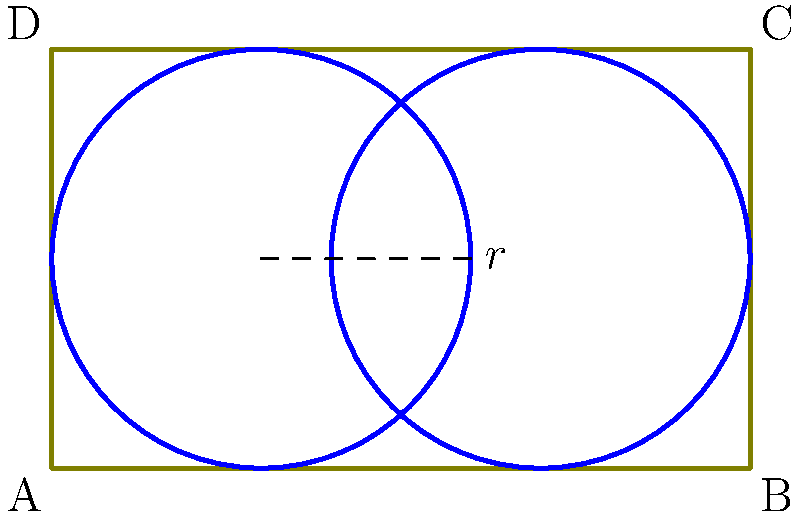As an agroecologist, you're designing an irrigation system for a rectangular field measuring 100 m by 60 m. You plan to use two circular pivot irrigation systems, each with a radius of 30 m. If the centers of the circles are placed on the long axis of the rectangle, what is the maximum percentage of the field that can be irrigated? Let's approach this step-by-step:

1) First, we need to calculate the total area of the field:
   Area of field = $100 \text{ m} \times 60 \text{ m} = 6000 \text{ m}^2$

2) The area of each circular irrigation system is:
   Area of circle = $\pi r^2 = \pi (30 \text{ m})^2 = 900\pi \text{ m}^2$

3) There are two circles, so the total irrigated area is:
   Total irrigated area = $2 \times 900\pi \text{ m}^2 = 1800\pi \text{ m}^2$

4) However, we need to check if the circles overlap or extend beyond the field:
   - The field is 100 m long, and each circle has a diameter of 60 m
   - If we place the centers of the circles 40 m apart (20 m from each end), they will just touch
   - This arrangement fits within the field and maximizes the irrigated area

5) Therefore, the maximum irrigated area is indeed $1800\pi \text{ m}^2$

6) To calculate the percentage, we divide the irrigated area by the total area and multiply by 100:
   Percentage irrigated = $\frac{1800\pi \text{ m}^2}{6000 \text{ m}^2} \times 100\% = 94.25\%$
Answer: 94.25% 